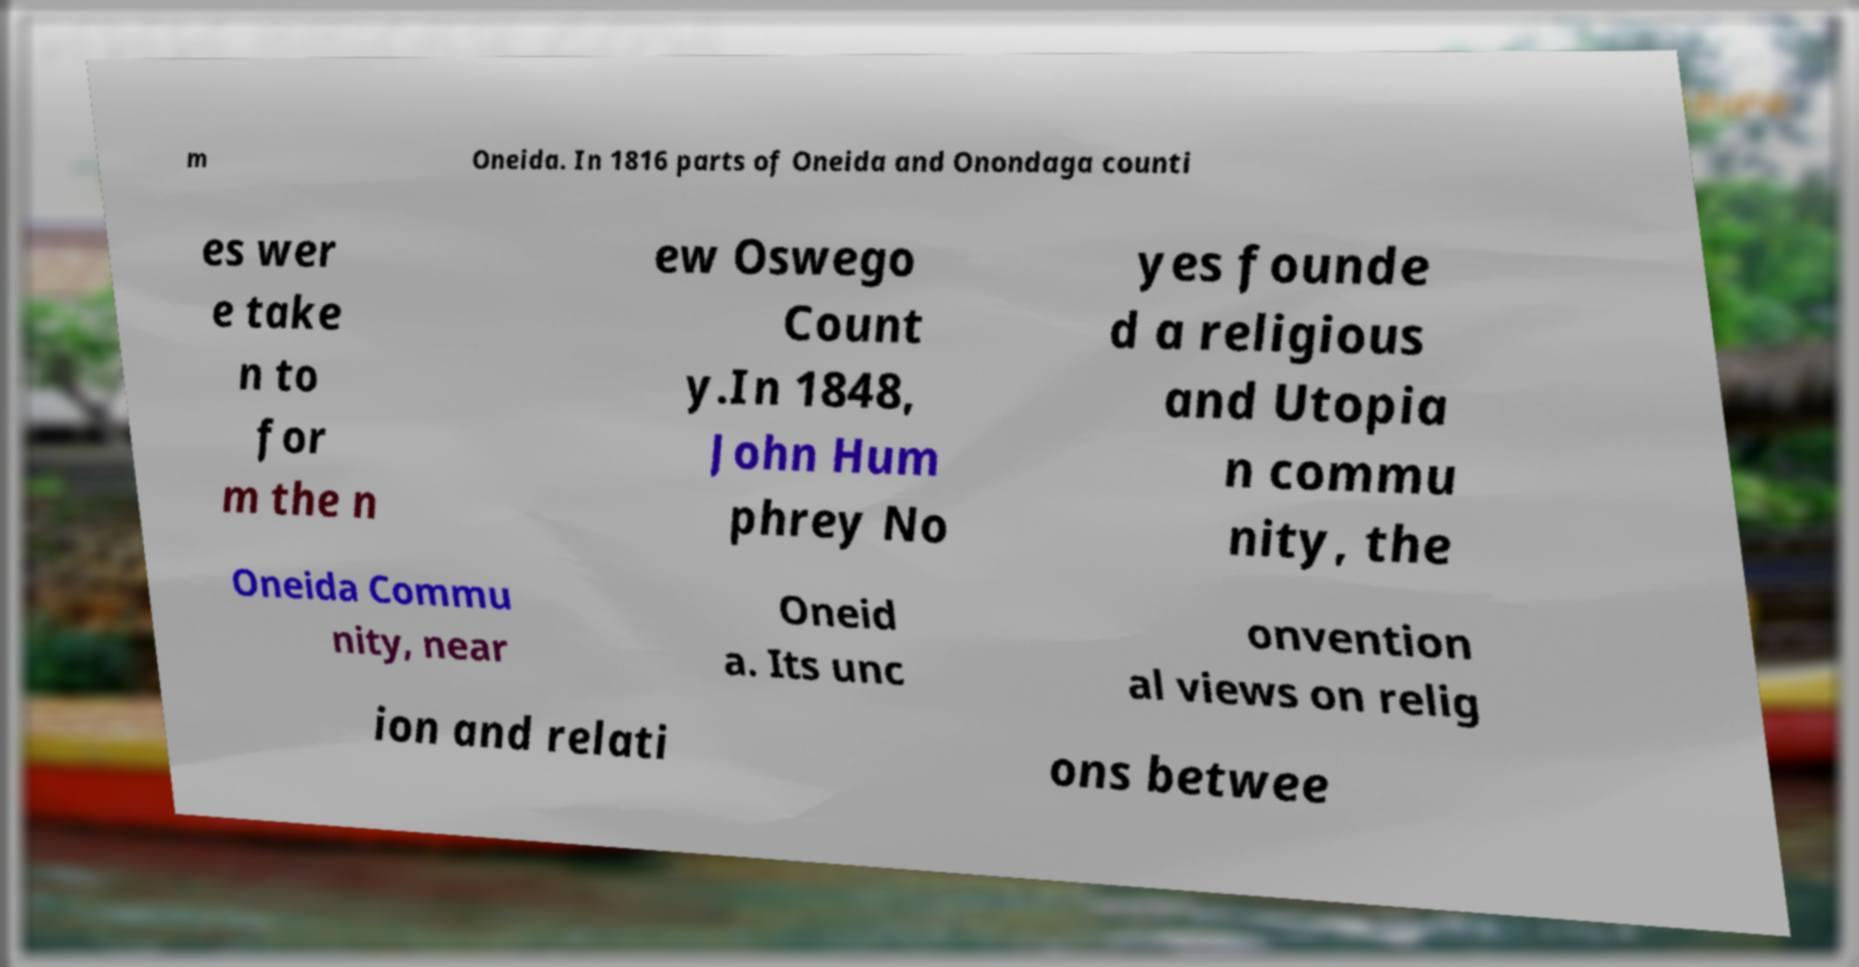Could you extract and type out the text from this image? m Oneida. In 1816 parts of Oneida and Onondaga counti es wer e take n to for m the n ew Oswego Count y.In 1848, John Hum phrey No yes founde d a religious and Utopia n commu nity, the Oneida Commu nity, near Oneid a. Its unc onvention al views on relig ion and relati ons betwee 